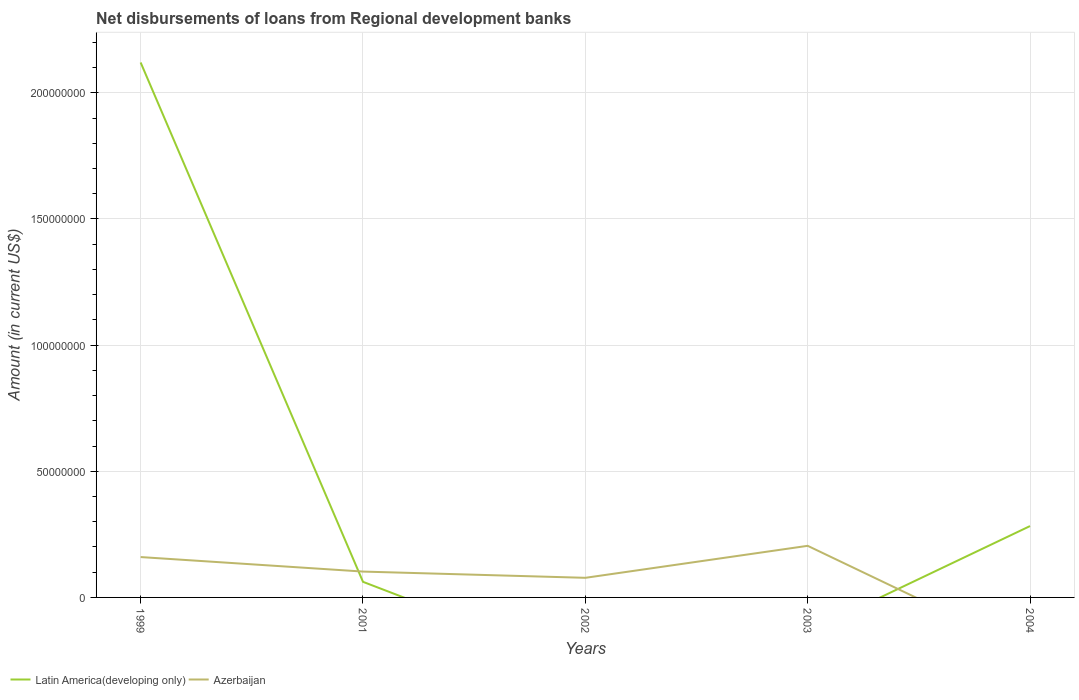What is the total amount of disbursements of loans from regional development banks in Azerbaijan in the graph?
Provide a succinct answer. -4.46e+06. What is the difference between the highest and the second highest amount of disbursements of loans from regional development banks in Latin America(developing only)?
Offer a very short reply. 2.12e+08. How many lines are there?
Offer a terse response. 2. How many years are there in the graph?
Ensure brevity in your answer.  5. Are the values on the major ticks of Y-axis written in scientific E-notation?
Give a very brief answer. No. Does the graph contain any zero values?
Provide a short and direct response. Yes. Where does the legend appear in the graph?
Your response must be concise. Bottom left. How many legend labels are there?
Ensure brevity in your answer.  2. What is the title of the graph?
Make the answer very short. Net disbursements of loans from Regional development banks. What is the label or title of the X-axis?
Ensure brevity in your answer.  Years. What is the label or title of the Y-axis?
Give a very brief answer. Amount (in current US$). What is the Amount (in current US$) of Latin America(developing only) in 1999?
Your response must be concise. 2.12e+08. What is the Amount (in current US$) of Azerbaijan in 1999?
Make the answer very short. 1.60e+07. What is the Amount (in current US$) in Latin America(developing only) in 2001?
Your response must be concise. 6.19e+06. What is the Amount (in current US$) in Azerbaijan in 2001?
Offer a terse response. 1.02e+07. What is the Amount (in current US$) in Azerbaijan in 2002?
Your answer should be very brief. 7.77e+06. What is the Amount (in current US$) of Azerbaijan in 2003?
Make the answer very short. 2.05e+07. What is the Amount (in current US$) of Latin America(developing only) in 2004?
Give a very brief answer. 2.83e+07. Across all years, what is the maximum Amount (in current US$) of Latin America(developing only)?
Your response must be concise. 2.12e+08. Across all years, what is the maximum Amount (in current US$) in Azerbaijan?
Make the answer very short. 2.05e+07. Across all years, what is the minimum Amount (in current US$) of Azerbaijan?
Keep it short and to the point. 0. What is the total Amount (in current US$) of Latin America(developing only) in the graph?
Make the answer very short. 2.47e+08. What is the total Amount (in current US$) in Azerbaijan in the graph?
Your answer should be very brief. 5.45e+07. What is the difference between the Amount (in current US$) in Latin America(developing only) in 1999 and that in 2001?
Provide a succinct answer. 2.06e+08. What is the difference between the Amount (in current US$) in Azerbaijan in 1999 and that in 2001?
Keep it short and to the point. 5.75e+06. What is the difference between the Amount (in current US$) in Azerbaijan in 1999 and that in 2002?
Your answer should be very brief. 8.23e+06. What is the difference between the Amount (in current US$) in Azerbaijan in 1999 and that in 2003?
Offer a very short reply. -4.46e+06. What is the difference between the Amount (in current US$) of Latin America(developing only) in 1999 and that in 2004?
Your response must be concise. 1.84e+08. What is the difference between the Amount (in current US$) of Azerbaijan in 2001 and that in 2002?
Provide a short and direct response. 2.48e+06. What is the difference between the Amount (in current US$) of Azerbaijan in 2001 and that in 2003?
Give a very brief answer. -1.02e+07. What is the difference between the Amount (in current US$) of Latin America(developing only) in 2001 and that in 2004?
Your response must be concise. -2.21e+07. What is the difference between the Amount (in current US$) in Azerbaijan in 2002 and that in 2003?
Offer a terse response. -1.27e+07. What is the difference between the Amount (in current US$) of Latin America(developing only) in 1999 and the Amount (in current US$) of Azerbaijan in 2001?
Provide a succinct answer. 2.02e+08. What is the difference between the Amount (in current US$) of Latin America(developing only) in 1999 and the Amount (in current US$) of Azerbaijan in 2002?
Provide a short and direct response. 2.04e+08. What is the difference between the Amount (in current US$) of Latin America(developing only) in 1999 and the Amount (in current US$) of Azerbaijan in 2003?
Your answer should be compact. 1.92e+08. What is the difference between the Amount (in current US$) in Latin America(developing only) in 2001 and the Amount (in current US$) in Azerbaijan in 2002?
Your answer should be compact. -1.59e+06. What is the difference between the Amount (in current US$) of Latin America(developing only) in 2001 and the Amount (in current US$) of Azerbaijan in 2003?
Provide a short and direct response. -1.43e+07. What is the average Amount (in current US$) in Latin America(developing only) per year?
Make the answer very short. 4.93e+07. What is the average Amount (in current US$) of Azerbaijan per year?
Make the answer very short. 1.09e+07. In the year 1999, what is the difference between the Amount (in current US$) in Latin America(developing only) and Amount (in current US$) in Azerbaijan?
Provide a succinct answer. 1.96e+08. In the year 2001, what is the difference between the Amount (in current US$) in Latin America(developing only) and Amount (in current US$) in Azerbaijan?
Your response must be concise. -4.06e+06. What is the ratio of the Amount (in current US$) of Latin America(developing only) in 1999 to that in 2001?
Your response must be concise. 34.27. What is the ratio of the Amount (in current US$) of Azerbaijan in 1999 to that in 2001?
Ensure brevity in your answer.  1.56. What is the ratio of the Amount (in current US$) in Azerbaijan in 1999 to that in 2002?
Your answer should be very brief. 2.06. What is the ratio of the Amount (in current US$) in Azerbaijan in 1999 to that in 2003?
Your answer should be very brief. 0.78. What is the ratio of the Amount (in current US$) in Latin America(developing only) in 1999 to that in 2004?
Offer a terse response. 7.5. What is the ratio of the Amount (in current US$) in Azerbaijan in 2001 to that in 2002?
Your answer should be compact. 1.32. What is the ratio of the Amount (in current US$) of Azerbaijan in 2001 to that in 2003?
Make the answer very short. 0.5. What is the ratio of the Amount (in current US$) in Latin America(developing only) in 2001 to that in 2004?
Keep it short and to the point. 0.22. What is the ratio of the Amount (in current US$) of Azerbaijan in 2002 to that in 2003?
Offer a terse response. 0.38. What is the difference between the highest and the second highest Amount (in current US$) of Latin America(developing only)?
Keep it short and to the point. 1.84e+08. What is the difference between the highest and the second highest Amount (in current US$) of Azerbaijan?
Offer a very short reply. 4.46e+06. What is the difference between the highest and the lowest Amount (in current US$) of Latin America(developing only)?
Offer a terse response. 2.12e+08. What is the difference between the highest and the lowest Amount (in current US$) in Azerbaijan?
Offer a terse response. 2.05e+07. 